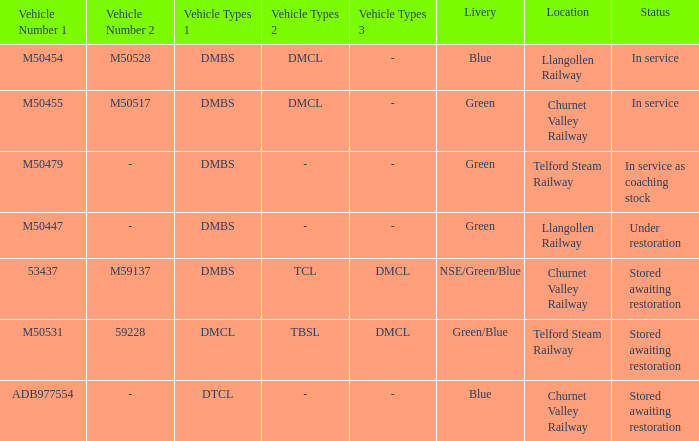What is the condition of the vehicle with the number adb977554? Stored awaiting restoration. 